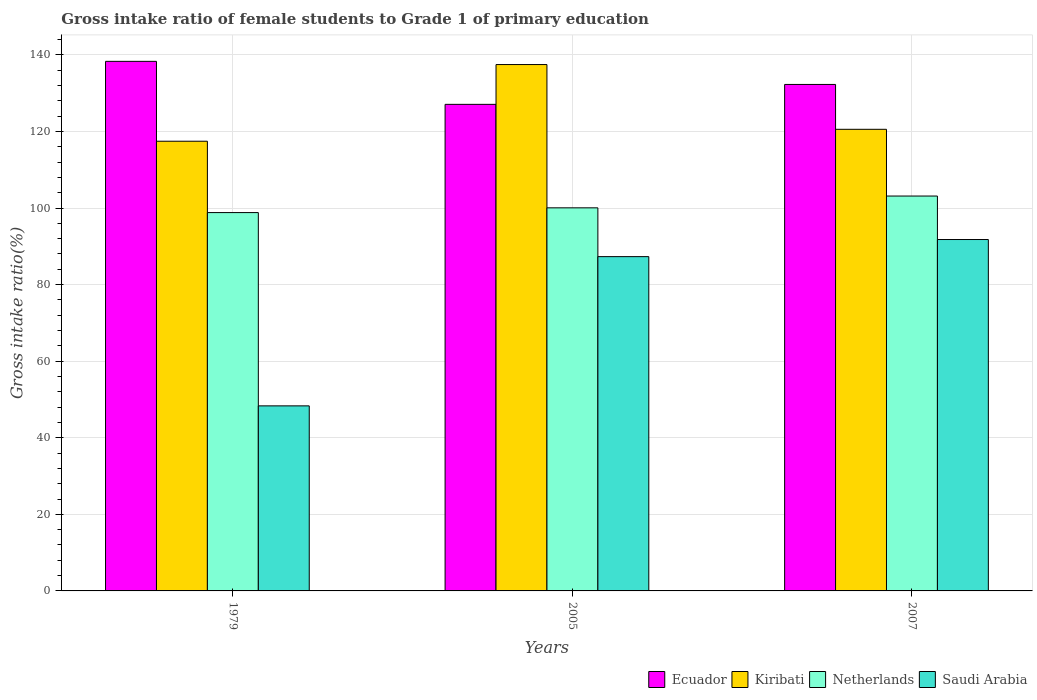Are the number of bars on each tick of the X-axis equal?
Make the answer very short. Yes. How many bars are there on the 3rd tick from the left?
Provide a short and direct response. 4. How many bars are there on the 1st tick from the right?
Your answer should be compact. 4. In how many cases, is the number of bars for a given year not equal to the number of legend labels?
Offer a very short reply. 0. What is the gross intake ratio in Saudi Arabia in 2007?
Ensure brevity in your answer.  91.78. Across all years, what is the maximum gross intake ratio in Ecuador?
Your response must be concise. 138.31. Across all years, what is the minimum gross intake ratio in Kiribati?
Ensure brevity in your answer.  117.45. In which year was the gross intake ratio in Saudi Arabia maximum?
Your answer should be compact. 2007. In which year was the gross intake ratio in Kiribati minimum?
Ensure brevity in your answer.  1979. What is the total gross intake ratio in Ecuador in the graph?
Your answer should be compact. 397.68. What is the difference between the gross intake ratio in Ecuador in 1979 and that in 2007?
Keep it short and to the point. 6.03. What is the difference between the gross intake ratio in Ecuador in 2005 and the gross intake ratio in Kiribati in 1979?
Offer a very short reply. 9.63. What is the average gross intake ratio in Netherlands per year?
Make the answer very short. 100.67. In the year 1979, what is the difference between the gross intake ratio in Ecuador and gross intake ratio in Saudi Arabia?
Give a very brief answer. 89.98. What is the ratio of the gross intake ratio in Kiribati in 1979 to that in 2007?
Your response must be concise. 0.97. What is the difference between the highest and the second highest gross intake ratio in Saudi Arabia?
Your answer should be very brief. 4.47. What is the difference between the highest and the lowest gross intake ratio in Netherlands?
Ensure brevity in your answer.  4.32. In how many years, is the gross intake ratio in Saudi Arabia greater than the average gross intake ratio in Saudi Arabia taken over all years?
Offer a terse response. 2. Is it the case that in every year, the sum of the gross intake ratio in Saudi Arabia and gross intake ratio in Ecuador is greater than the sum of gross intake ratio in Netherlands and gross intake ratio in Kiribati?
Your answer should be compact. Yes. What does the 4th bar from the left in 2005 represents?
Offer a very short reply. Saudi Arabia. What does the 1st bar from the right in 1979 represents?
Provide a succinct answer. Saudi Arabia. Are all the bars in the graph horizontal?
Provide a succinct answer. No. How many years are there in the graph?
Offer a very short reply. 3. What is the difference between two consecutive major ticks on the Y-axis?
Your answer should be compact. 20. Are the values on the major ticks of Y-axis written in scientific E-notation?
Keep it short and to the point. No. Does the graph contain any zero values?
Ensure brevity in your answer.  No. Does the graph contain grids?
Keep it short and to the point. Yes. Where does the legend appear in the graph?
Give a very brief answer. Bottom right. How many legend labels are there?
Your answer should be very brief. 4. What is the title of the graph?
Keep it short and to the point. Gross intake ratio of female students to Grade 1 of primary education. Does "Malaysia" appear as one of the legend labels in the graph?
Provide a succinct answer. No. What is the label or title of the X-axis?
Offer a very short reply. Years. What is the label or title of the Y-axis?
Give a very brief answer. Gross intake ratio(%). What is the Gross intake ratio(%) in Ecuador in 1979?
Make the answer very short. 138.31. What is the Gross intake ratio(%) in Kiribati in 1979?
Make the answer very short. 117.45. What is the Gross intake ratio(%) in Netherlands in 1979?
Give a very brief answer. 98.81. What is the Gross intake ratio(%) of Saudi Arabia in 1979?
Your answer should be compact. 48.33. What is the Gross intake ratio(%) in Ecuador in 2005?
Ensure brevity in your answer.  127.08. What is the Gross intake ratio(%) of Kiribati in 2005?
Give a very brief answer. 137.48. What is the Gross intake ratio(%) in Netherlands in 2005?
Ensure brevity in your answer.  100.05. What is the Gross intake ratio(%) of Saudi Arabia in 2005?
Provide a short and direct response. 87.31. What is the Gross intake ratio(%) in Ecuador in 2007?
Your answer should be compact. 132.28. What is the Gross intake ratio(%) of Kiribati in 2007?
Your response must be concise. 120.56. What is the Gross intake ratio(%) of Netherlands in 2007?
Ensure brevity in your answer.  103.14. What is the Gross intake ratio(%) in Saudi Arabia in 2007?
Your answer should be compact. 91.78. Across all years, what is the maximum Gross intake ratio(%) of Ecuador?
Make the answer very short. 138.31. Across all years, what is the maximum Gross intake ratio(%) of Kiribati?
Give a very brief answer. 137.48. Across all years, what is the maximum Gross intake ratio(%) in Netherlands?
Provide a succinct answer. 103.14. Across all years, what is the maximum Gross intake ratio(%) of Saudi Arabia?
Ensure brevity in your answer.  91.78. Across all years, what is the minimum Gross intake ratio(%) of Ecuador?
Offer a terse response. 127.08. Across all years, what is the minimum Gross intake ratio(%) in Kiribati?
Provide a succinct answer. 117.45. Across all years, what is the minimum Gross intake ratio(%) of Netherlands?
Give a very brief answer. 98.81. Across all years, what is the minimum Gross intake ratio(%) in Saudi Arabia?
Give a very brief answer. 48.33. What is the total Gross intake ratio(%) of Ecuador in the graph?
Keep it short and to the point. 397.68. What is the total Gross intake ratio(%) of Kiribati in the graph?
Provide a short and direct response. 375.49. What is the total Gross intake ratio(%) in Netherlands in the graph?
Provide a short and direct response. 302. What is the total Gross intake ratio(%) of Saudi Arabia in the graph?
Make the answer very short. 227.42. What is the difference between the Gross intake ratio(%) of Ecuador in 1979 and that in 2005?
Your answer should be compact. 11.23. What is the difference between the Gross intake ratio(%) in Kiribati in 1979 and that in 2005?
Keep it short and to the point. -20.02. What is the difference between the Gross intake ratio(%) of Netherlands in 1979 and that in 2005?
Offer a very short reply. -1.24. What is the difference between the Gross intake ratio(%) of Saudi Arabia in 1979 and that in 2005?
Provide a succinct answer. -38.98. What is the difference between the Gross intake ratio(%) in Ecuador in 1979 and that in 2007?
Give a very brief answer. 6.03. What is the difference between the Gross intake ratio(%) in Kiribati in 1979 and that in 2007?
Provide a succinct answer. -3.11. What is the difference between the Gross intake ratio(%) of Netherlands in 1979 and that in 2007?
Make the answer very short. -4.32. What is the difference between the Gross intake ratio(%) of Saudi Arabia in 1979 and that in 2007?
Offer a terse response. -43.45. What is the difference between the Gross intake ratio(%) in Ecuador in 2005 and that in 2007?
Your answer should be very brief. -5.2. What is the difference between the Gross intake ratio(%) of Kiribati in 2005 and that in 2007?
Provide a short and direct response. 16.91. What is the difference between the Gross intake ratio(%) of Netherlands in 2005 and that in 2007?
Make the answer very short. -3.08. What is the difference between the Gross intake ratio(%) of Saudi Arabia in 2005 and that in 2007?
Give a very brief answer. -4.47. What is the difference between the Gross intake ratio(%) of Ecuador in 1979 and the Gross intake ratio(%) of Kiribati in 2005?
Provide a succinct answer. 0.83. What is the difference between the Gross intake ratio(%) of Ecuador in 1979 and the Gross intake ratio(%) of Netherlands in 2005?
Your response must be concise. 38.26. What is the difference between the Gross intake ratio(%) in Ecuador in 1979 and the Gross intake ratio(%) in Saudi Arabia in 2005?
Your answer should be very brief. 51. What is the difference between the Gross intake ratio(%) of Kiribati in 1979 and the Gross intake ratio(%) of Netherlands in 2005?
Ensure brevity in your answer.  17.4. What is the difference between the Gross intake ratio(%) in Kiribati in 1979 and the Gross intake ratio(%) in Saudi Arabia in 2005?
Your answer should be very brief. 30.14. What is the difference between the Gross intake ratio(%) of Netherlands in 1979 and the Gross intake ratio(%) of Saudi Arabia in 2005?
Offer a terse response. 11.51. What is the difference between the Gross intake ratio(%) of Ecuador in 1979 and the Gross intake ratio(%) of Kiribati in 2007?
Provide a short and direct response. 17.75. What is the difference between the Gross intake ratio(%) of Ecuador in 1979 and the Gross intake ratio(%) of Netherlands in 2007?
Give a very brief answer. 35.18. What is the difference between the Gross intake ratio(%) in Ecuador in 1979 and the Gross intake ratio(%) in Saudi Arabia in 2007?
Provide a succinct answer. 46.53. What is the difference between the Gross intake ratio(%) in Kiribati in 1979 and the Gross intake ratio(%) in Netherlands in 2007?
Offer a terse response. 14.32. What is the difference between the Gross intake ratio(%) of Kiribati in 1979 and the Gross intake ratio(%) of Saudi Arabia in 2007?
Your answer should be very brief. 25.67. What is the difference between the Gross intake ratio(%) in Netherlands in 1979 and the Gross intake ratio(%) in Saudi Arabia in 2007?
Make the answer very short. 7.04. What is the difference between the Gross intake ratio(%) of Ecuador in 2005 and the Gross intake ratio(%) of Kiribati in 2007?
Ensure brevity in your answer.  6.52. What is the difference between the Gross intake ratio(%) of Ecuador in 2005 and the Gross intake ratio(%) of Netherlands in 2007?
Provide a short and direct response. 23.95. What is the difference between the Gross intake ratio(%) of Ecuador in 2005 and the Gross intake ratio(%) of Saudi Arabia in 2007?
Your response must be concise. 35.3. What is the difference between the Gross intake ratio(%) in Kiribati in 2005 and the Gross intake ratio(%) in Netherlands in 2007?
Your answer should be compact. 34.34. What is the difference between the Gross intake ratio(%) of Kiribati in 2005 and the Gross intake ratio(%) of Saudi Arabia in 2007?
Your response must be concise. 45.7. What is the difference between the Gross intake ratio(%) in Netherlands in 2005 and the Gross intake ratio(%) in Saudi Arabia in 2007?
Offer a terse response. 8.27. What is the average Gross intake ratio(%) of Ecuador per year?
Offer a terse response. 132.56. What is the average Gross intake ratio(%) in Kiribati per year?
Give a very brief answer. 125.16. What is the average Gross intake ratio(%) of Netherlands per year?
Your answer should be compact. 100.67. What is the average Gross intake ratio(%) of Saudi Arabia per year?
Provide a succinct answer. 75.81. In the year 1979, what is the difference between the Gross intake ratio(%) in Ecuador and Gross intake ratio(%) in Kiribati?
Ensure brevity in your answer.  20.86. In the year 1979, what is the difference between the Gross intake ratio(%) of Ecuador and Gross intake ratio(%) of Netherlands?
Make the answer very short. 39.5. In the year 1979, what is the difference between the Gross intake ratio(%) of Ecuador and Gross intake ratio(%) of Saudi Arabia?
Your answer should be compact. 89.98. In the year 1979, what is the difference between the Gross intake ratio(%) in Kiribati and Gross intake ratio(%) in Netherlands?
Offer a terse response. 18.64. In the year 1979, what is the difference between the Gross intake ratio(%) in Kiribati and Gross intake ratio(%) in Saudi Arabia?
Your answer should be very brief. 69.12. In the year 1979, what is the difference between the Gross intake ratio(%) of Netherlands and Gross intake ratio(%) of Saudi Arabia?
Offer a terse response. 50.48. In the year 2005, what is the difference between the Gross intake ratio(%) in Ecuador and Gross intake ratio(%) in Kiribati?
Offer a terse response. -10.39. In the year 2005, what is the difference between the Gross intake ratio(%) in Ecuador and Gross intake ratio(%) in Netherlands?
Provide a succinct answer. 27.03. In the year 2005, what is the difference between the Gross intake ratio(%) in Ecuador and Gross intake ratio(%) in Saudi Arabia?
Your answer should be very brief. 39.77. In the year 2005, what is the difference between the Gross intake ratio(%) of Kiribati and Gross intake ratio(%) of Netherlands?
Your answer should be compact. 37.42. In the year 2005, what is the difference between the Gross intake ratio(%) of Kiribati and Gross intake ratio(%) of Saudi Arabia?
Offer a very short reply. 50.17. In the year 2005, what is the difference between the Gross intake ratio(%) of Netherlands and Gross intake ratio(%) of Saudi Arabia?
Your response must be concise. 12.74. In the year 2007, what is the difference between the Gross intake ratio(%) in Ecuador and Gross intake ratio(%) in Kiribati?
Offer a terse response. 11.72. In the year 2007, what is the difference between the Gross intake ratio(%) in Ecuador and Gross intake ratio(%) in Netherlands?
Offer a terse response. 29.15. In the year 2007, what is the difference between the Gross intake ratio(%) in Ecuador and Gross intake ratio(%) in Saudi Arabia?
Keep it short and to the point. 40.5. In the year 2007, what is the difference between the Gross intake ratio(%) of Kiribati and Gross intake ratio(%) of Netherlands?
Offer a very short reply. 17.43. In the year 2007, what is the difference between the Gross intake ratio(%) of Kiribati and Gross intake ratio(%) of Saudi Arabia?
Your answer should be compact. 28.78. In the year 2007, what is the difference between the Gross intake ratio(%) in Netherlands and Gross intake ratio(%) in Saudi Arabia?
Offer a very short reply. 11.36. What is the ratio of the Gross intake ratio(%) of Ecuador in 1979 to that in 2005?
Offer a very short reply. 1.09. What is the ratio of the Gross intake ratio(%) of Kiribati in 1979 to that in 2005?
Make the answer very short. 0.85. What is the ratio of the Gross intake ratio(%) of Netherlands in 1979 to that in 2005?
Your answer should be very brief. 0.99. What is the ratio of the Gross intake ratio(%) of Saudi Arabia in 1979 to that in 2005?
Give a very brief answer. 0.55. What is the ratio of the Gross intake ratio(%) in Ecuador in 1979 to that in 2007?
Your response must be concise. 1.05. What is the ratio of the Gross intake ratio(%) in Kiribati in 1979 to that in 2007?
Provide a short and direct response. 0.97. What is the ratio of the Gross intake ratio(%) of Netherlands in 1979 to that in 2007?
Make the answer very short. 0.96. What is the ratio of the Gross intake ratio(%) of Saudi Arabia in 1979 to that in 2007?
Make the answer very short. 0.53. What is the ratio of the Gross intake ratio(%) of Ecuador in 2005 to that in 2007?
Your answer should be compact. 0.96. What is the ratio of the Gross intake ratio(%) of Kiribati in 2005 to that in 2007?
Provide a short and direct response. 1.14. What is the ratio of the Gross intake ratio(%) of Netherlands in 2005 to that in 2007?
Your answer should be compact. 0.97. What is the ratio of the Gross intake ratio(%) in Saudi Arabia in 2005 to that in 2007?
Offer a terse response. 0.95. What is the difference between the highest and the second highest Gross intake ratio(%) in Ecuador?
Offer a very short reply. 6.03. What is the difference between the highest and the second highest Gross intake ratio(%) of Kiribati?
Your answer should be very brief. 16.91. What is the difference between the highest and the second highest Gross intake ratio(%) in Netherlands?
Provide a succinct answer. 3.08. What is the difference between the highest and the second highest Gross intake ratio(%) of Saudi Arabia?
Keep it short and to the point. 4.47. What is the difference between the highest and the lowest Gross intake ratio(%) in Ecuador?
Give a very brief answer. 11.23. What is the difference between the highest and the lowest Gross intake ratio(%) of Kiribati?
Provide a succinct answer. 20.02. What is the difference between the highest and the lowest Gross intake ratio(%) of Netherlands?
Make the answer very short. 4.32. What is the difference between the highest and the lowest Gross intake ratio(%) in Saudi Arabia?
Offer a terse response. 43.45. 